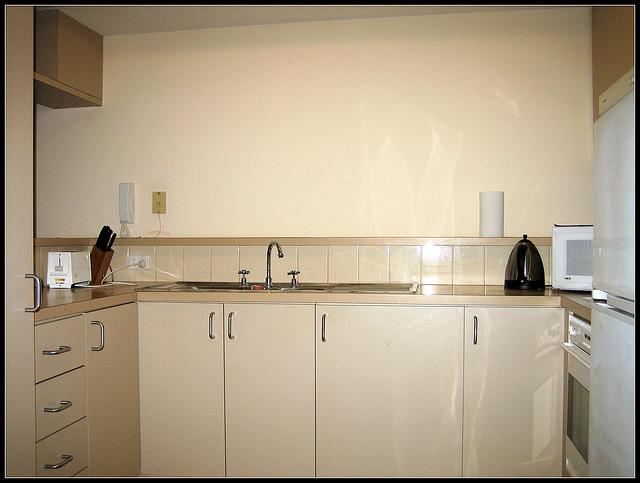Is there a bicycle in this picture?
Keep it brief. No. What color is dominant?
Answer briefly. White. What is the black doomed object on th countertop?
Concise answer only. Kettle. What is in the photo?
Quick response, please. Kitchen. How many cats?
Quick response, please. 0. 